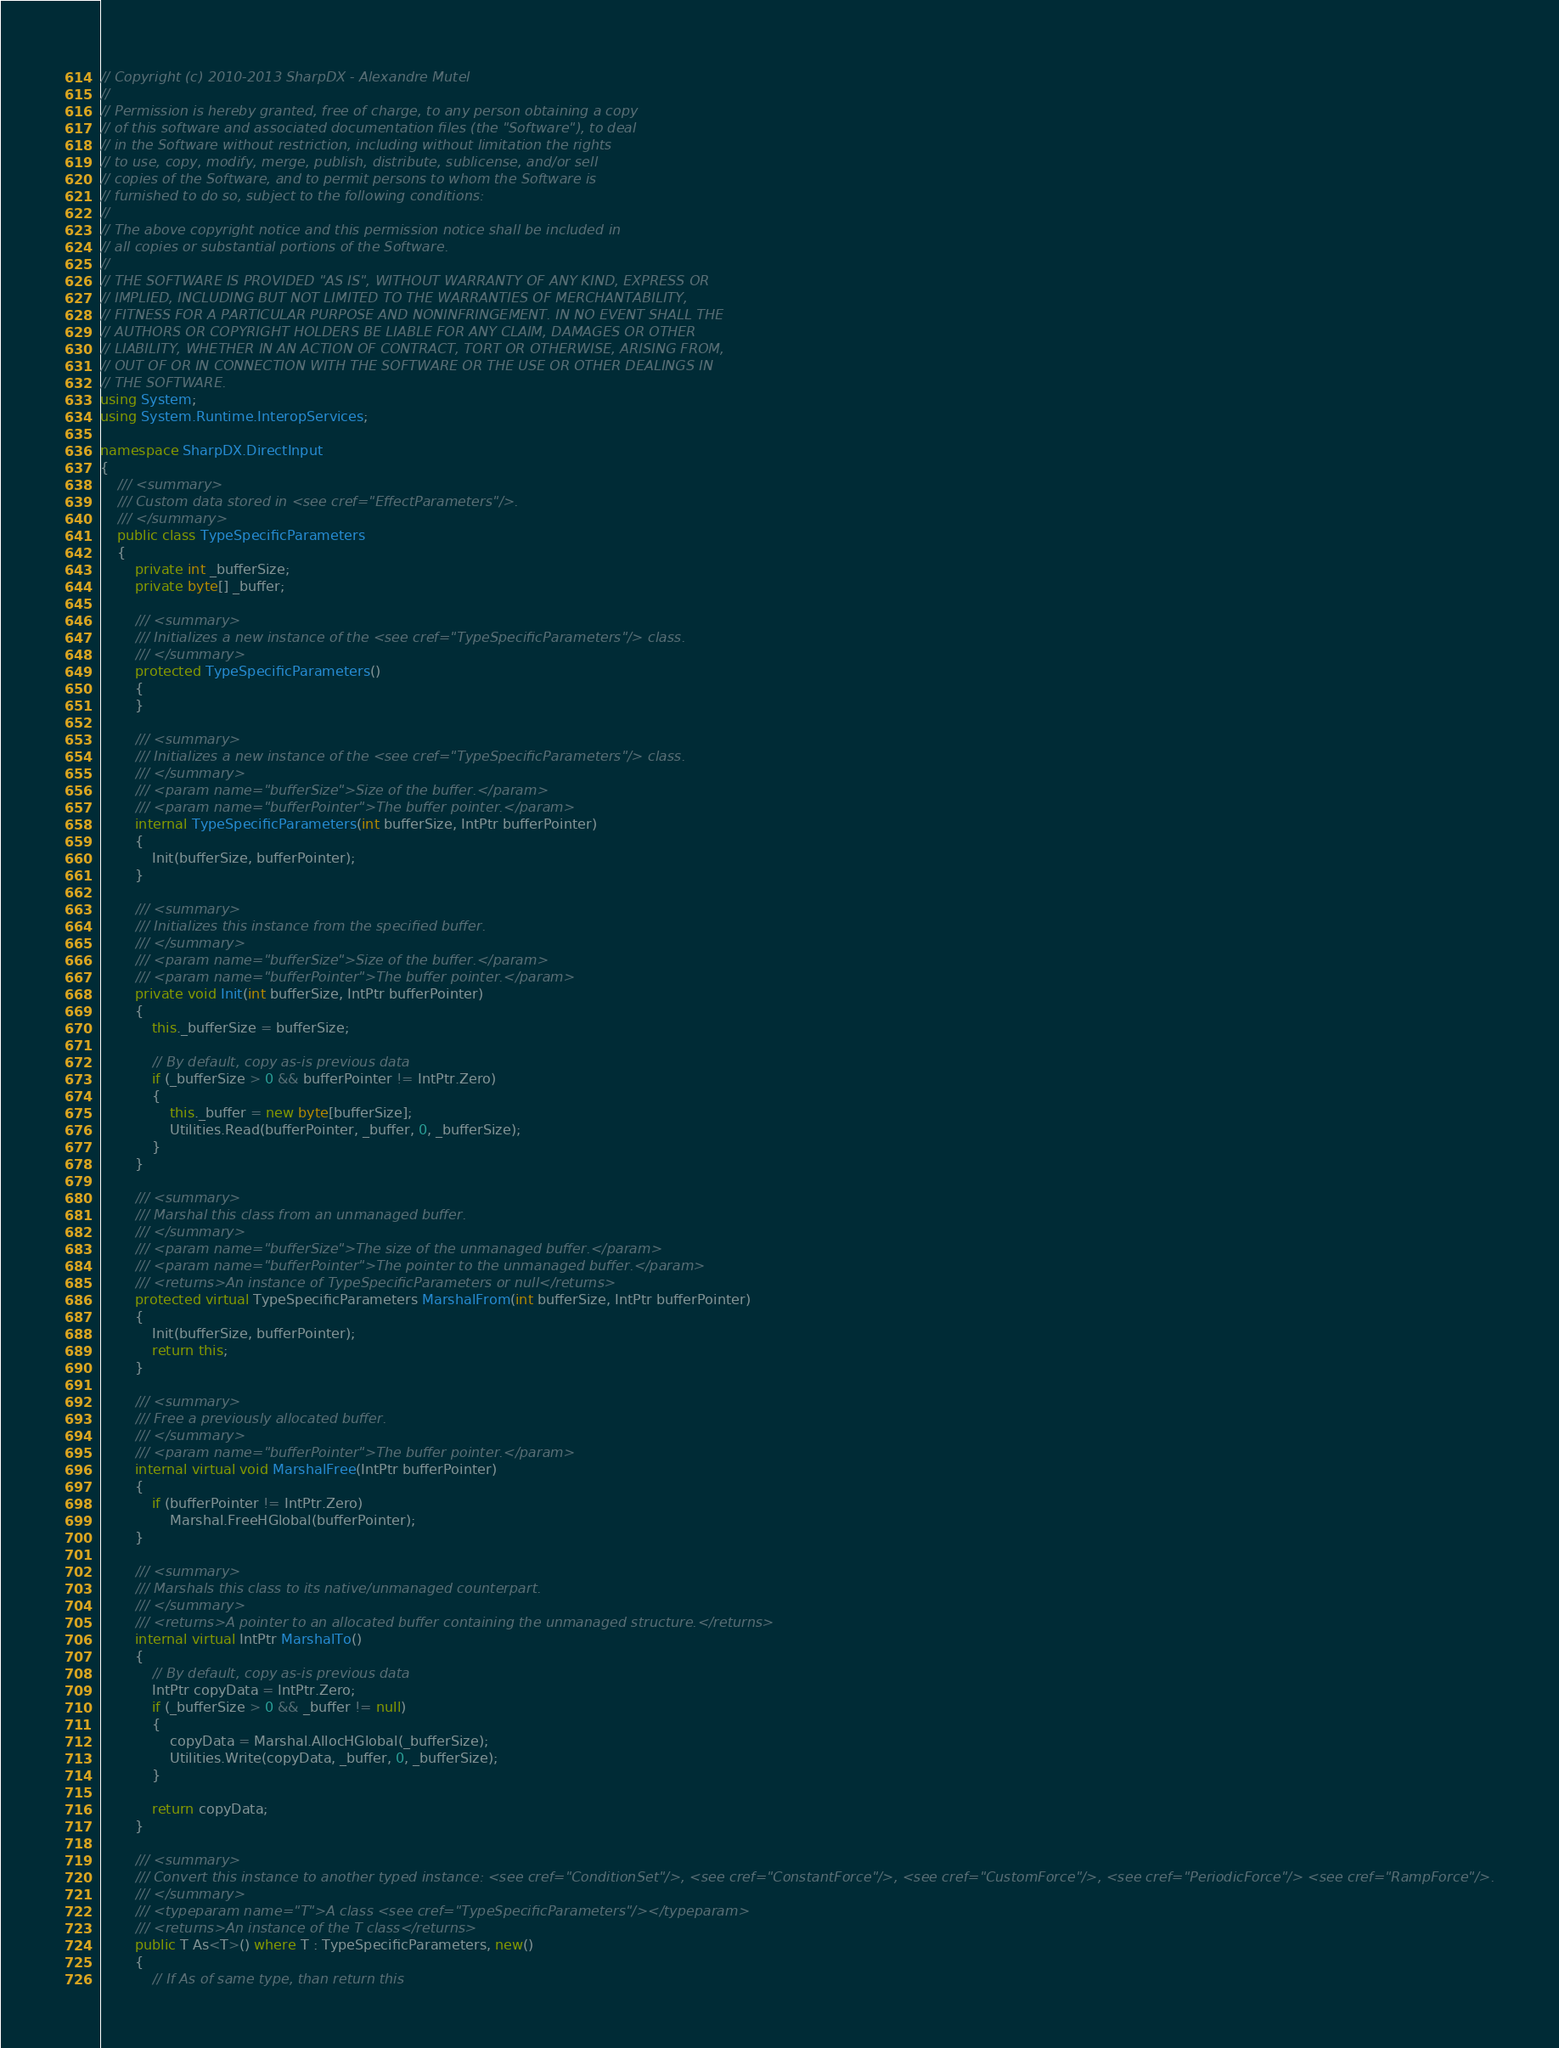Convert code to text. <code><loc_0><loc_0><loc_500><loc_500><_C#_>// Copyright (c) 2010-2013 SharpDX - Alexandre Mutel
// 
// Permission is hereby granted, free of charge, to any person obtaining a copy
// of this software and associated documentation files (the "Software"), to deal
// in the Software without restriction, including without limitation the rights
// to use, copy, modify, merge, publish, distribute, sublicense, and/or sell
// copies of the Software, and to permit persons to whom the Software is
// furnished to do so, subject to the following conditions:
// 
// The above copyright notice and this permission notice shall be included in
// all copies or substantial portions of the Software.
// 
// THE SOFTWARE IS PROVIDED "AS IS", WITHOUT WARRANTY OF ANY KIND, EXPRESS OR
// IMPLIED, INCLUDING BUT NOT LIMITED TO THE WARRANTIES OF MERCHANTABILITY,
// FITNESS FOR A PARTICULAR PURPOSE AND NONINFRINGEMENT. IN NO EVENT SHALL THE
// AUTHORS OR COPYRIGHT HOLDERS BE LIABLE FOR ANY CLAIM, DAMAGES OR OTHER
// LIABILITY, WHETHER IN AN ACTION OF CONTRACT, TORT OR OTHERWISE, ARISING FROM,
// OUT OF OR IN CONNECTION WITH THE SOFTWARE OR THE USE OR OTHER DEALINGS IN
// THE SOFTWARE.
using System;
using System.Runtime.InteropServices;

namespace SharpDX.DirectInput
{
    /// <summary>
    /// Custom data stored in <see cref="EffectParameters"/>.
    /// </summary>
    public class TypeSpecificParameters
    {
        private int _bufferSize;
        private byte[] _buffer;

        /// <summary>
        /// Initializes a new instance of the <see cref="TypeSpecificParameters"/> class.
        /// </summary>
        protected TypeSpecificParameters()
        {
        }

        /// <summary>
        /// Initializes a new instance of the <see cref="TypeSpecificParameters"/> class.
        /// </summary>
        /// <param name="bufferSize">Size of the buffer.</param>
        /// <param name="bufferPointer">The buffer pointer.</param>
        internal TypeSpecificParameters(int bufferSize, IntPtr bufferPointer)
        {
            Init(bufferSize, bufferPointer);
        }

        /// <summary>
        /// Initializes this instance from the specified buffer.
        /// </summary>
        /// <param name="bufferSize">Size of the buffer.</param>
        /// <param name="bufferPointer">The buffer pointer.</param>
        private void Init(int bufferSize, IntPtr bufferPointer)
        {
            this._bufferSize = bufferSize;

            // By default, copy as-is previous data
            if (_bufferSize > 0 && bufferPointer != IntPtr.Zero)
            {
                this._buffer = new byte[bufferSize];
                Utilities.Read(bufferPointer, _buffer, 0, _bufferSize);
            }            
        }

        /// <summary>
        /// Marshal this class from an unmanaged buffer.
        /// </summary>
        /// <param name="bufferSize">The size of the unmanaged buffer.</param>
        /// <param name="bufferPointer">The pointer to the unmanaged buffer.</param>
        /// <returns>An instance of TypeSpecificParameters or null</returns>
        protected virtual TypeSpecificParameters MarshalFrom(int bufferSize, IntPtr bufferPointer)
        {
            Init(bufferSize, bufferPointer);
            return this;
        }

        /// <summary>
        /// Free a previously allocated buffer.
        /// </summary>
        /// <param name="bufferPointer">The buffer pointer.</param>
        internal virtual void MarshalFree(IntPtr bufferPointer)
        {
            if (bufferPointer != IntPtr.Zero)
                Marshal.FreeHGlobal(bufferPointer);
        }

        /// <summary>
        /// Marshals this class to its native/unmanaged counterpart.
        /// </summary>
        /// <returns>A pointer to an allocated buffer containing the unmanaged structure.</returns>
        internal virtual IntPtr MarshalTo()
        {
            // By default, copy as-is previous data
            IntPtr copyData = IntPtr.Zero;
            if (_bufferSize > 0 && _buffer != null)
            {
                copyData = Marshal.AllocHGlobal(_bufferSize);
                Utilities.Write(copyData, _buffer, 0, _bufferSize);
            }
            
            return copyData;
        }

        /// <summary>
        /// Convert this instance to another typed instance: <see cref="ConditionSet"/>, <see cref="ConstantForce"/>, <see cref="CustomForce"/>, <see cref="PeriodicForce"/> <see cref="RampForce"/>.
        /// </summary>
        /// <typeparam name="T">A class <see cref="TypeSpecificParameters"/></typeparam>
        /// <returns>An instance of the T class</returns>
        public T As<T>() where T : TypeSpecificParameters, new()
        {
            // If As of same type, than return this</code> 